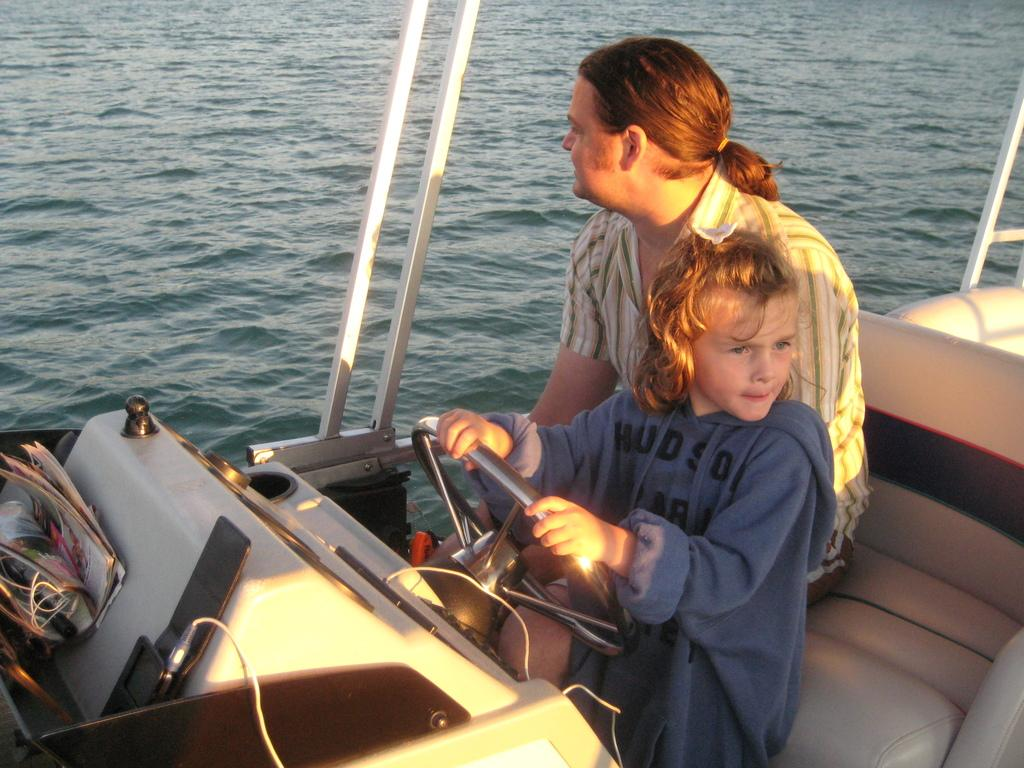Who is present in the boat in the image? There is a man and a girl in the boat in the image. What is the girl holding in the image? The girl is holding a steering in the image. What else can be seen in the boat besides the people? There are papers and cables in the boat. What can be seen in the background of the image? The background of the image includes water and rods. What type of chair can be seen in the image? There is no chair present in the image. What book is the girl reading in the image? There is no book visible in the image; the girl is holding a steering. 